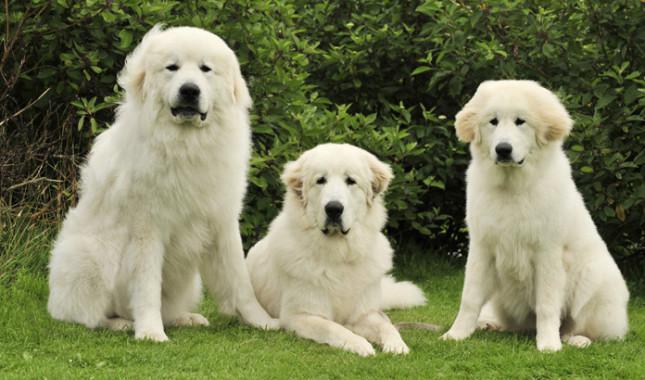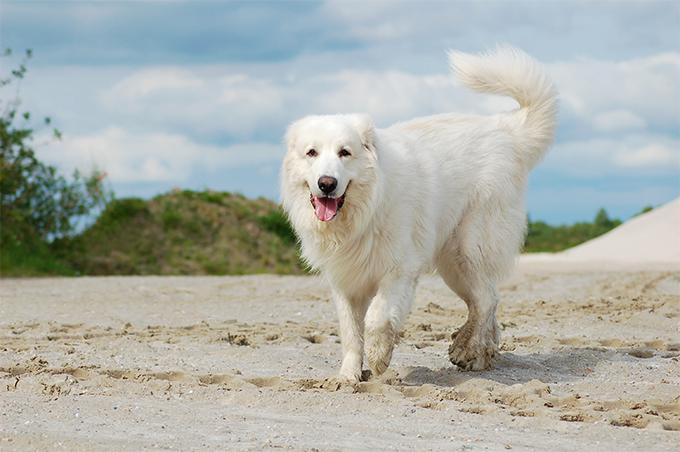The first image is the image on the left, the second image is the image on the right. Analyze the images presented: Is the assertion "One image contains more than one dog." valid? Answer yes or no. Yes. The first image is the image on the left, the second image is the image on the right. Assess this claim about the two images: "There are no more than two dogs.". Correct or not? Answer yes or no. No. 